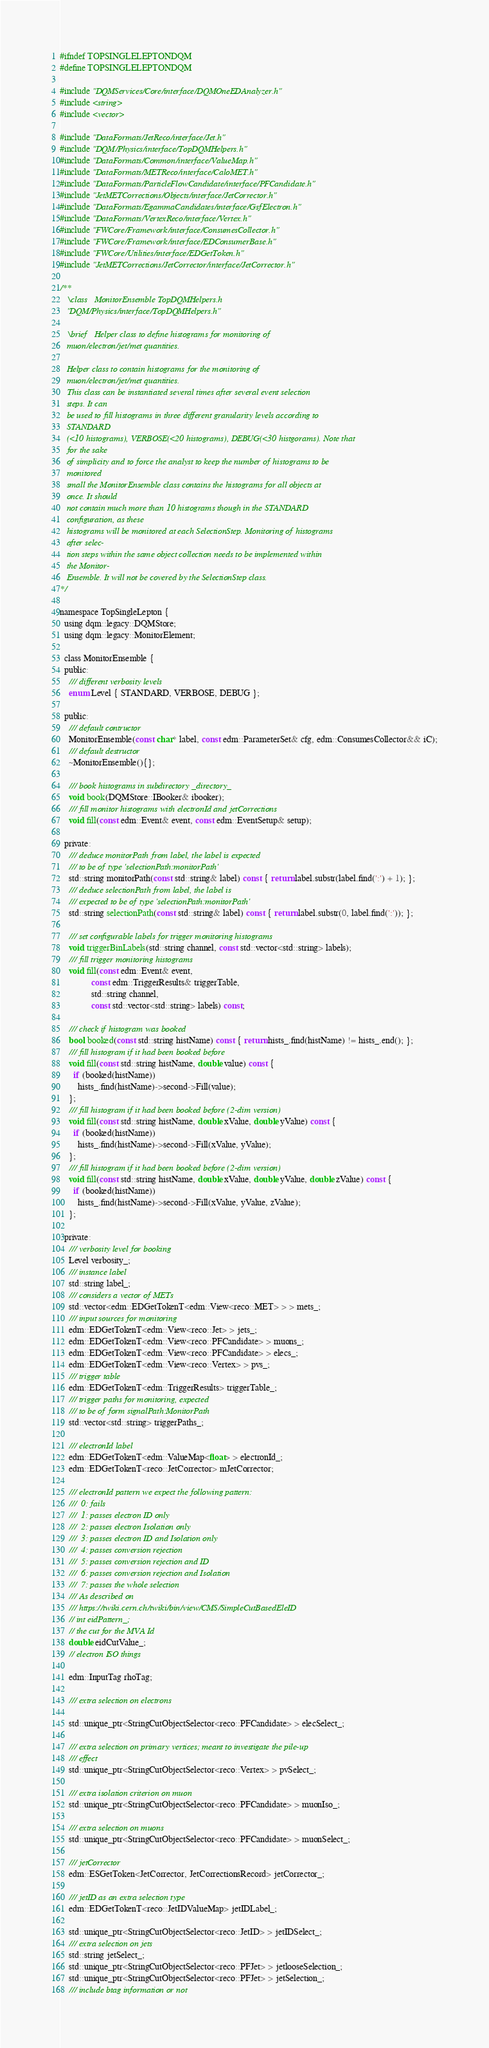<code> <loc_0><loc_0><loc_500><loc_500><_C_>#ifndef TOPSINGLELEPTONDQM
#define TOPSINGLELEPTONDQM

#include "DQMServices/Core/interface/DQMOneEDAnalyzer.h"
#include <string>
#include <vector>

#include "DataFormats/JetReco/interface/Jet.h"
#include "DQM/Physics/interface/TopDQMHelpers.h"
#include "DataFormats/Common/interface/ValueMap.h"
#include "DataFormats/METReco/interface/CaloMET.h"
#include "DataFormats/ParticleFlowCandidate/interface/PFCandidate.h"
#include "JetMETCorrections/Objects/interface/JetCorrector.h"
#include "DataFormats/EgammaCandidates/interface/GsfElectron.h"
#include "DataFormats/VertexReco/interface/Vertex.h"
#include "FWCore/Framework/interface/ConsumesCollector.h"
#include "FWCore/Framework/interface/EDConsumerBase.h"
#include "FWCore/Utilities/interface/EDGetToken.h"
#include "JetMETCorrections/JetCorrector/interface/JetCorrector.h"

/**
   \class   MonitorEnsemble TopDQMHelpers.h
   "DQM/Physics/interface/TopDQMHelpers.h"

   \brief   Helper class to define histograms for monitoring of
   muon/electron/jet/met quantities.

   Helper class to contain histograms for the monitoring of
   muon/electron/jet/met quantities.
   This class can be instantiated several times after several event selection
   steps. It can
   be used to fill histograms in three different granularity levels according to
   STANDARD
   (<10 histograms), VERBOSE(<20 histograms), DEBUG(<30 histgorams). Note that
   for the sake
   of simplicity and to force the analyst to keep the number of histograms to be
   monitored
   small the MonitorEnsemble class contains the histograms for all objects at
   once. It should
   not contain much more than 10 histograms though in the STANDARD
   configuration, as these
   histograms will be monitored at each SelectionStep. Monitoring of histograms
   after selec-
   tion steps within the same object collection needs to be implemented within
   the Monitor-
   Ensemble. It will not be covered by the SelectionStep class.
*/

namespace TopSingleLepton {
  using dqm::legacy::DQMStore;
  using dqm::legacy::MonitorElement;

  class MonitorEnsemble {
  public:
    /// different verbosity levels
    enum Level { STANDARD, VERBOSE, DEBUG };

  public:
    /// default contructor
    MonitorEnsemble(const char* label, const edm::ParameterSet& cfg, edm::ConsumesCollector&& iC);
    /// default destructor
    ~MonitorEnsemble(){};

    /// book histograms in subdirectory _directory_
    void book(DQMStore::IBooker& ibooker);
    /// fill monitor histograms with electronId and jetCorrections
    void fill(const edm::Event& event, const edm::EventSetup& setup);

  private:
    /// deduce monitorPath from label, the label is expected
    /// to be of type 'selectionPath:monitorPath'
    std::string monitorPath(const std::string& label) const { return label.substr(label.find(':') + 1); };
    /// deduce selectionPath from label, the label is
    /// expected to be of type 'selectionPath:monitorPath'
    std::string selectionPath(const std::string& label) const { return label.substr(0, label.find(':')); };

    /// set configurable labels for trigger monitoring histograms
    void triggerBinLabels(std::string channel, const std::vector<std::string> labels);
    /// fill trigger monitoring histograms
    void fill(const edm::Event& event,
              const edm::TriggerResults& triggerTable,
              std::string channel,
              const std::vector<std::string> labels) const;

    /// check if histogram was booked
    bool booked(const std::string histName) const { return hists_.find(histName) != hists_.end(); };
    /// fill histogram if it had been booked before
    void fill(const std::string histName, double value) const {
      if (booked(histName))
        hists_.find(histName)->second->Fill(value);
    };
    /// fill histogram if it had been booked before (2-dim version)
    void fill(const std::string histName, double xValue, double yValue) const {
      if (booked(histName))
        hists_.find(histName)->second->Fill(xValue, yValue);
    };
    /// fill histogram if it had been booked before (2-dim version)
    void fill(const std::string histName, double xValue, double yValue, double zValue) const {
      if (booked(histName))
        hists_.find(histName)->second->Fill(xValue, yValue, zValue);
    };

  private:
    /// verbosity level for booking
    Level verbosity_;
    /// instance label
    std::string label_;
    /// considers a vector of METs
    std::vector<edm::EDGetTokenT<edm::View<reco::MET> > > mets_;
    /// input sources for monitoring
    edm::EDGetTokenT<edm::View<reco::Jet> > jets_;
    edm::EDGetTokenT<edm::View<reco::PFCandidate> > muons_;
    edm::EDGetTokenT<edm::View<reco::PFCandidate> > elecs_;
    edm::EDGetTokenT<edm::View<reco::Vertex> > pvs_;
    /// trigger table
    edm::EDGetTokenT<edm::TriggerResults> triggerTable_;
    /// trigger paths for monitoring, expected
    /// to be of form signalPath:MonitorPath
    std::vector<std::string> triggerPaths_;

    /// electronId label
    edm::EDGetTokenT<edm::ValueMap<float> > electronId_;
    edm::EDGetTokenT<reco::JetCorrector> mJetCorrector;

    /// electronId pattern we expect the following pattern:
    ///  0: fails
    ///  1: passes electron ID only
    ///  2: passes electron Isolation only
    ///  3: passes electron ID and Isolation only
    ///  4: passes conversion rejection
    ///  5: passes conversion rejection and ID
    ///  6: passes conversion rejection and Isolation
    ///  7: passes the whole selection
    /// As described on
    /// https://twiki.cern.ch/twiki/bin/view/CMS/SimpleCutBasedEleID
    // int eidPattern_;
    // the cut for the MVA Id
    double eidCutValue_;
    // electron ISO things

    edm::InputTag rhoTag;

    /// extra selection on electrons

    std::unique_ptr<StringCutObjectSelector<reco::PFCandidate> > elecSelect_;

    /// extra selection on primary vertices; meant to investigate the pile-up
    /// effect
    std::unique_ptr<StringCutObjectSelector<reco::Vertex> > pvSelect_;

    /// extra isolation criterion on muon
    std::unique_ptr<StringCutObjectSelector<reco::PFCandidate> > muonIso_;

    /// extra selection on muons
    std::unique_ptr<StringCutObjectSelector<reco::PFCandidate> > muonSelect_;

    /// jetCorrector
    edm::ESGetToken<JetCorrector, JetCorrectionsRecord> jetCorrector_;

    /// jetID as an extra selection type
    edm::EDGetTokenT<reco::JetIDValueMap> jetIDLabel_;

    std::unique_ptr<StringCutObjectSelector<reco::JetID> > jetIDSelect_;
    /// extra selection on jets
    std::string jetSelect_;
    std::unique_ptr<StringCutObjectSelector<reco::PFJet> > jetlooseSelection_;
    std::unique_ptr<StringCutObjectSelector<reco::PFJet> > jetSelection_;
    /// include btag information or not</code> 